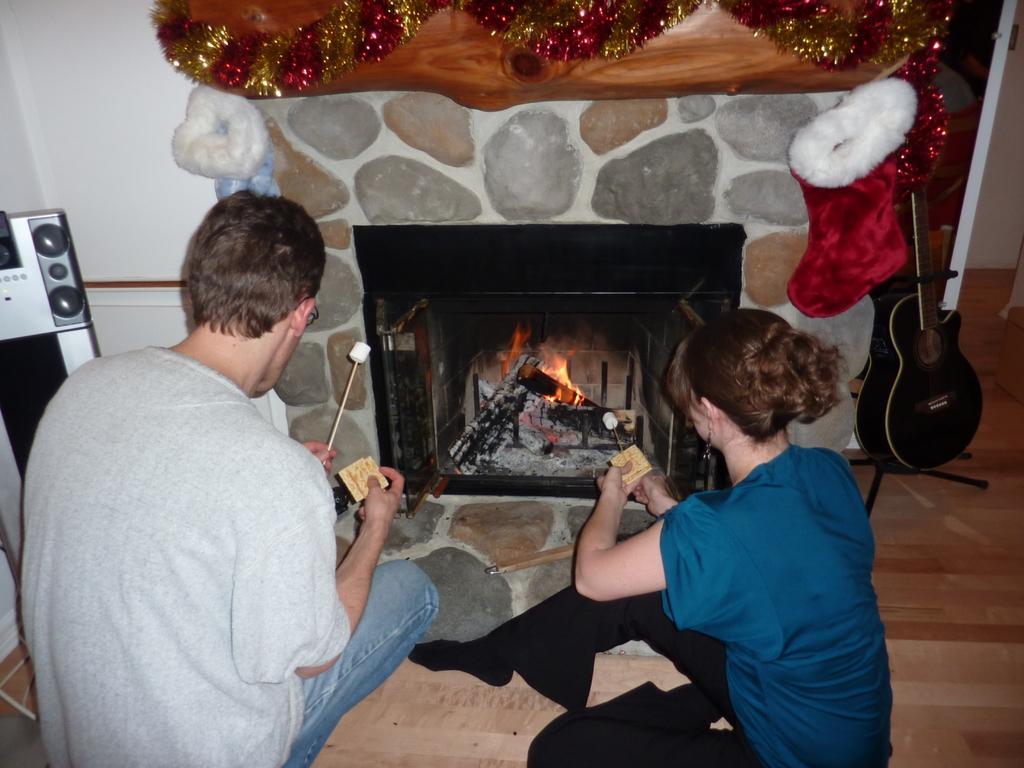Please provide a concise description of this image. This image consists of two persons sitting on the floor. In the middle, there is a fireplace. To the right, there is a guitar. To the left, there are speakers. In the background, there is a wall. 